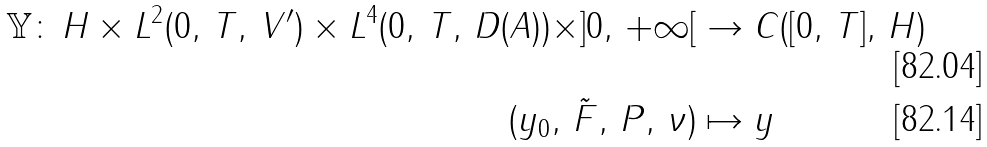Convert formula to latex. <formula><loc_0><loc_0><loc_500><loc_500>\mathbb { Y } \colon \, H \times L ^ { 2 } ( 0 , \, T , \, V ^ { \prime } ) \times L ^ { 4 } ( 0 , \, T , \, D ( A ) ) \times ] 0 , \, + \infty [ & \to C ( [ 0 , \, T ] , \, H ) \\ ( y _ { 0 } , \, \tilde { F } , \, P , \, \nu ) & \mapsto y</formula> 